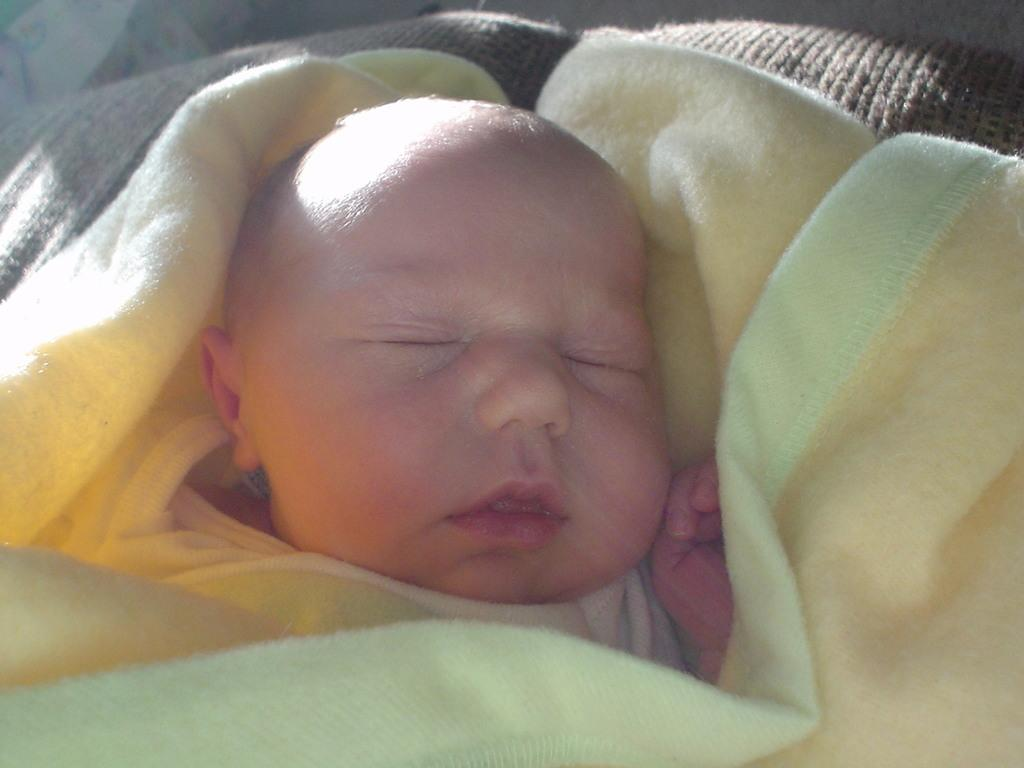What is the main subject of the image? There is a baby in the image. Where is the baby located? The baby is lying on a bed. What else can be seen in the image? There is a blanket in the image. Can you describe the setting of the image? The image is likely taken in a room. How many potatoes are visible in the image? There are no potatoes present in the image. What type of pies can be seen on the bed with the baby? There are no pies visible in the image. 